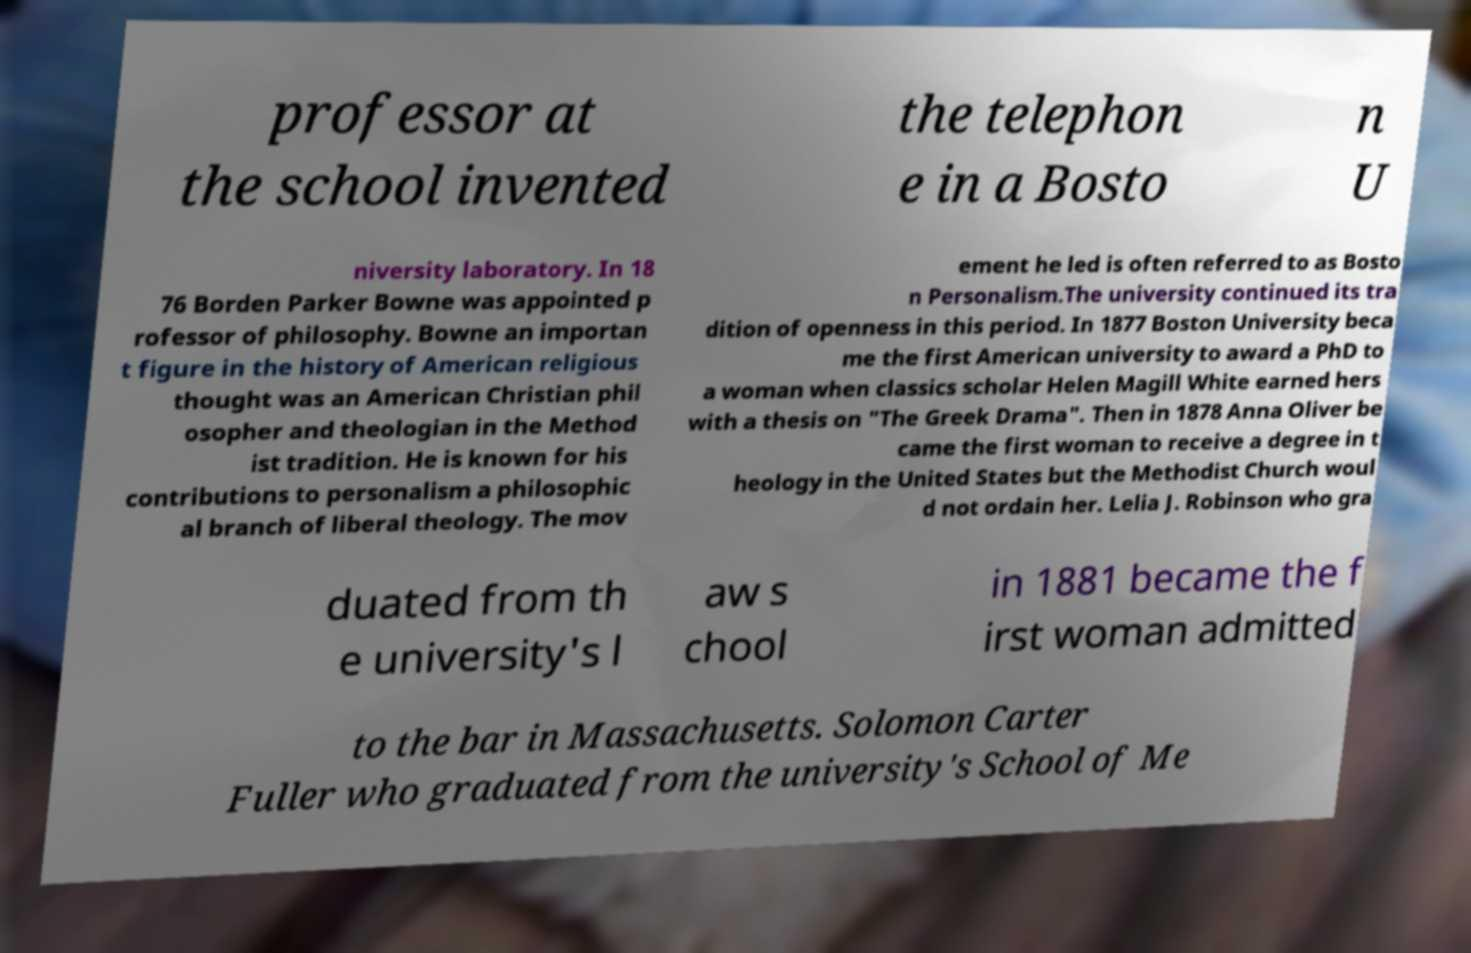Could you extract and type out the text from this image? professor at the school invented the telephon e in a Bosto n U niversity laboratory. In 18 76 Borden Parker Bowne was appointed p rofessor of philosophy. Bowne an importan t figure in the history of American religious thought was an American Christian phil osopher and theologian in the Method ist tradition. He is known for his contributions to personalism a philosophic al branch of liberal theology. The mov ement he led is often referred to as Bosto n Personalism.The university continued its tra dition of openness in this period. In 1877 Boston University beca me the first American university to award a PhD to a woman when classics scholar Helen Magill White earned hers with a thesis on "The Greek Drama". Then in 1878 Anna Oliver be came the first woman to receive a degree in t heology in the United States but the Methodist Church woul d not ordain her. Lelia J. Robinson who gra duated from th e university's l aw s chool in 1881 became the f irst woman admitted to the bar in Massachusetts. Solomon Carter Fuller who graduated from the university's School of Me 